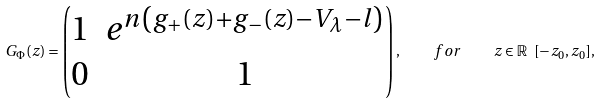<formula> <loc_0><loc_0><loc_500><loc_500>G _ { \Phi } ( z ) = \begin{pmatrix} 1 & e ^ { n \left ( g _ { + } ( z ) + g _ { - } ( z ) - V _ { \lambda } - l \right ) } \\ 0 & 1 \end{pmatrix} , \quad f o r \quad z \in { \mathbb { R } } \ [ - z _ { 0 } , z _ { 0 } ] ,</formula> 